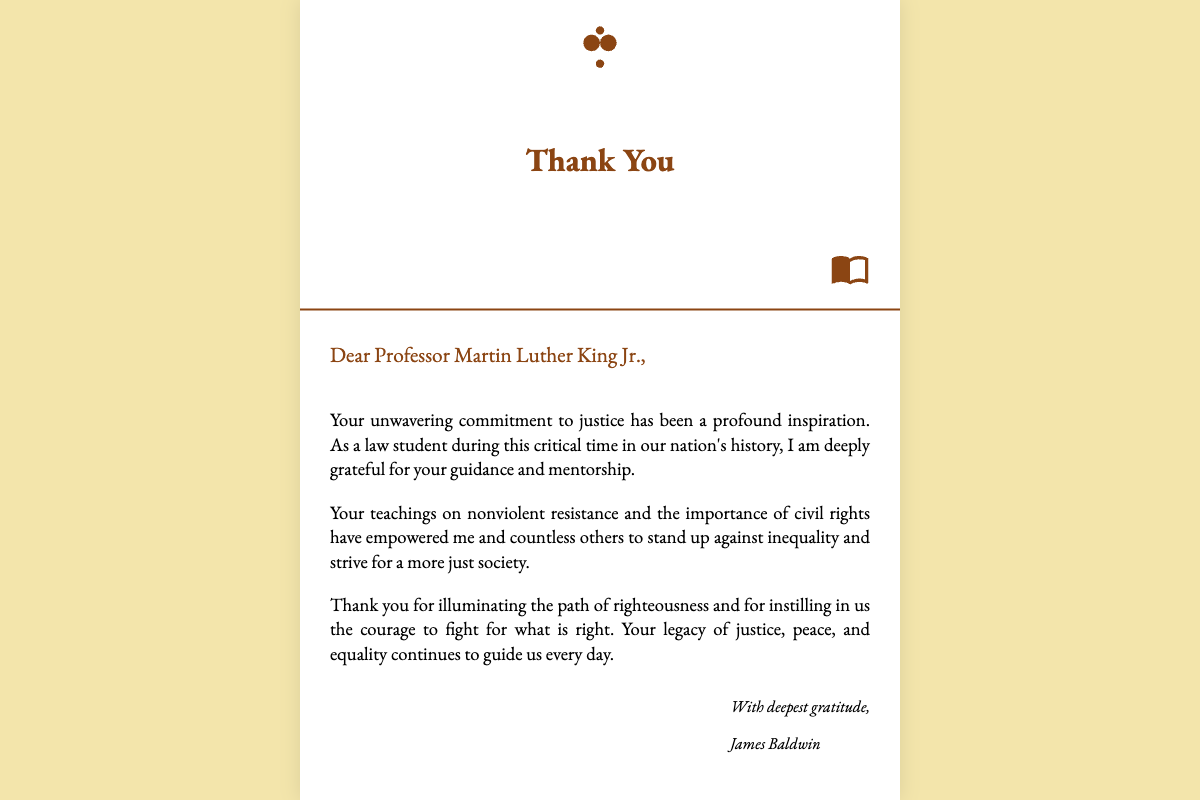What is the name of the professor addressed in the card? The name of the professor is explicitly mentioned in the greeting as "Professor Martin Luther King Jr."
Answer: Professor Martin Luther King Jr What is the color of the card's background? The background color of the card is specified in the CSS as "#F3E5AB."
Answer: #F3E5AB What is the headline text on the front cover? The headline text is displayed prominently on the front cover of the card as "Thank You."
Answer: Thank You How many paragraphs are in the inside message? The inside message consists of three paragraphs, as evidenced by the provided HTML structure.
Answer: 3 What does the greeting start with? The greeting begins with "Dear Professor Martin Luther King Jr.," which is the opening line of the inside message.
Answer: Dear Professor Martin Luther King Jr Who is the sender of the card? The sender of the card is identified at the end of the inside message as "James Baldwin."
Answer: James Baldwin What does the card express gratitude for? The card expresses gratitude for the professor's "unwavering commitment to justice" and his mentorship.
Answer: unwavering commitment to justice What imagery is used on the front cover of the card? The front cover features illustrations of law books and a scale of justice as part of its design elements.
Answer: law books and scale of justice 